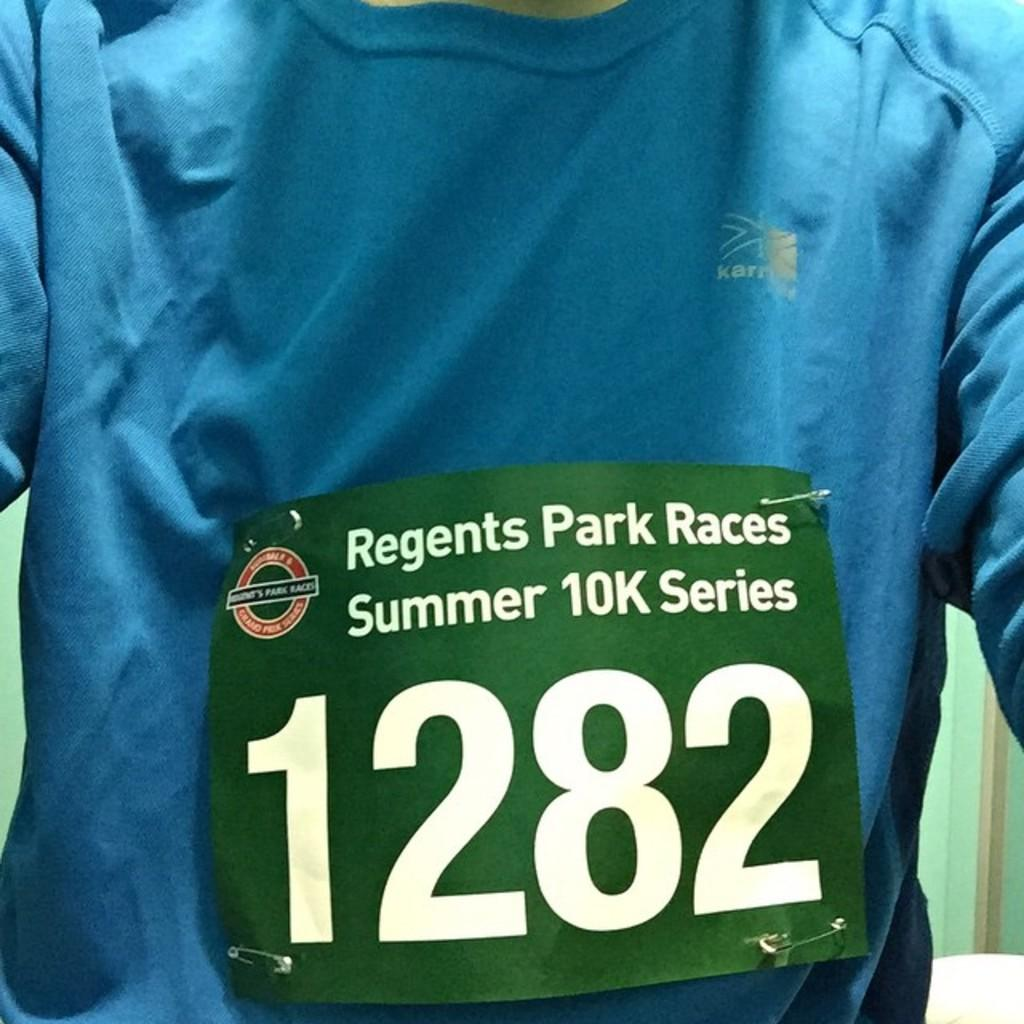<image>
Give a short and clear explanation of the subsequent image. Regents Park Races Summer 10K Series entrant numbers included 1282. 